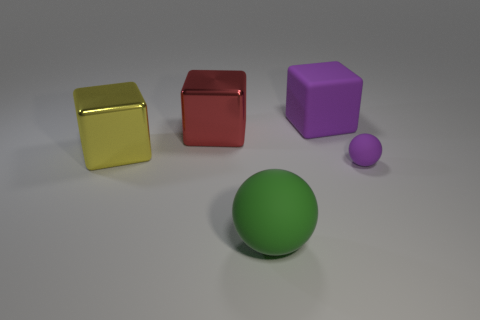How is the lighting in this scene affecting the appearance of the objects? The lighting in the scene casts soft shadows and gives the objects a gentle contrast against the gray background. It appears to be diffused, causing the colors of the objects to stand out without harsh reflections. Does the lighting indicate a specific time of day or type of environment? The lighting doesn't strongly indicate a specific time of day as it seems to be a controlled indoor setting. The evenness and the lack of a distinct light source suggest studio lighting commonly used in 3D renderings or product photography. 